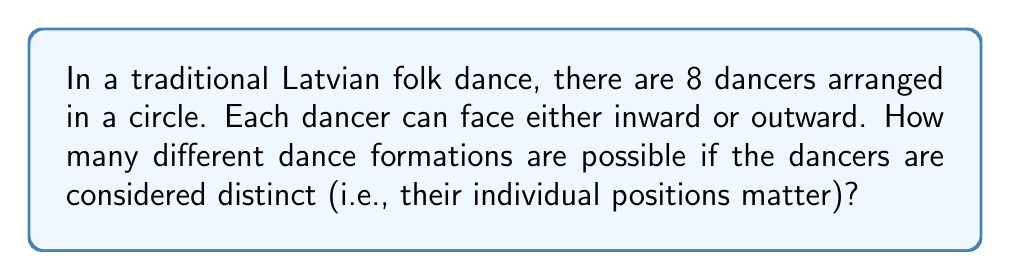What is the answer to this math problem? Let's approach this step-by-step:

1) We have 8 dancers, each with 2 possible orientations (facing inward or outward).

2) For each dancer, we have 2 choices, and these choices are independent of each other.

3) This scenario follows the multiplication principle of counting.

4) The total number of possible formations is given by the number of choices raised to the power of the number of dancers:

   $$2^8$$

5) We can calculate this:
   $$2^8 = 2 \times 2 \times 2 \times 2 \times 2 \times 2 \times 2 \times 2 = 256$$

Therefore, there are 256 possible dance formations.
Answer: 256 